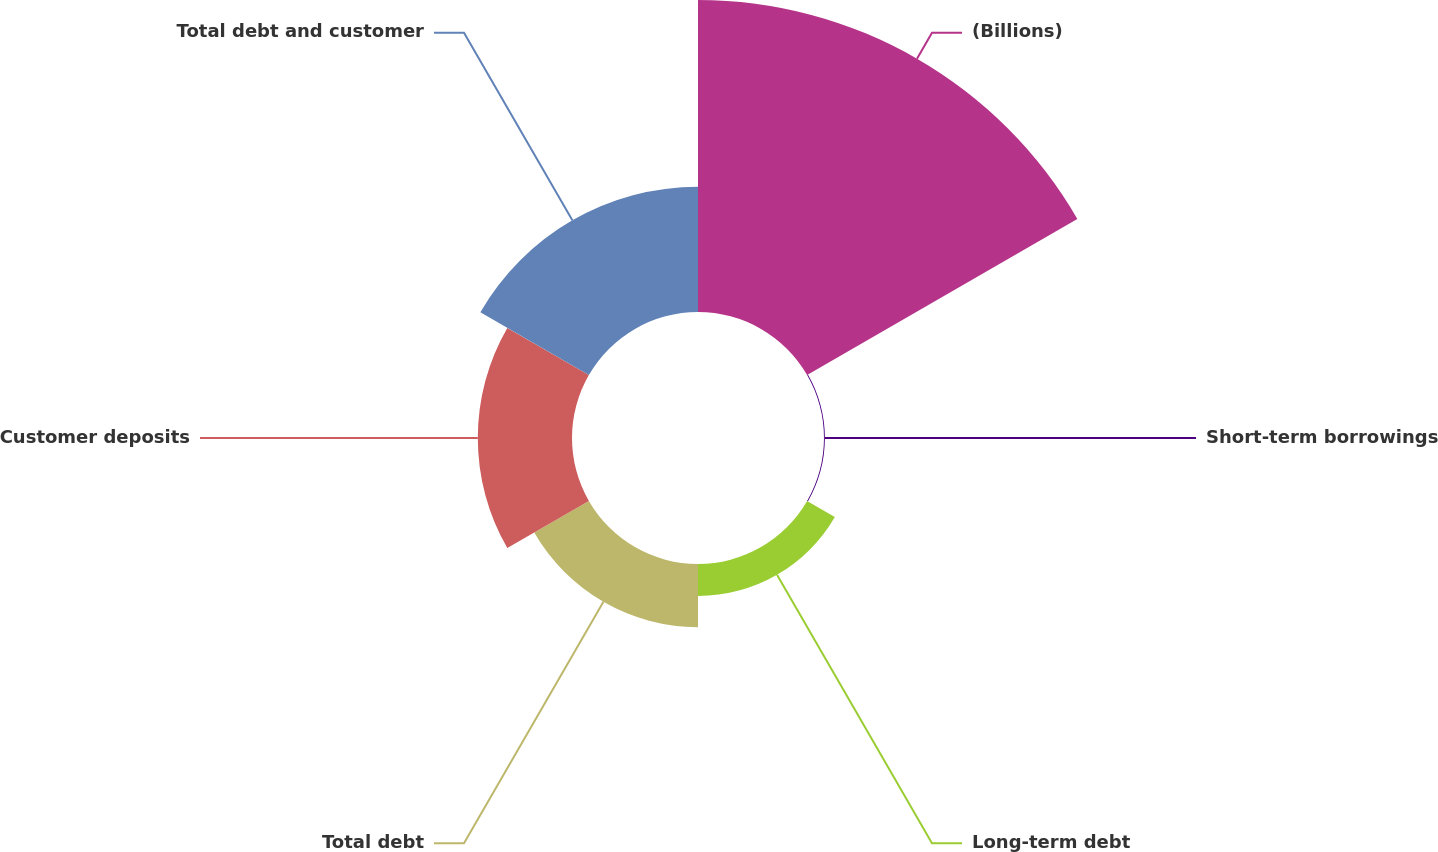Convert chart to OTSL. <chart><loc_0><loc_0><loc_500><loc_500><pie_chart><fcel>(Billions)<fcel>Short-term borrowings<fcel>Long-term debt<fcel>Total debt<fcel>Customer deposits<fcel>Total debt and customer<nl><fcel>49.72%<fcel>0.14%<fcel>5.1%<fcel>10.06%<fcel>15.01%<fcel>19.97%<nl></chart> 